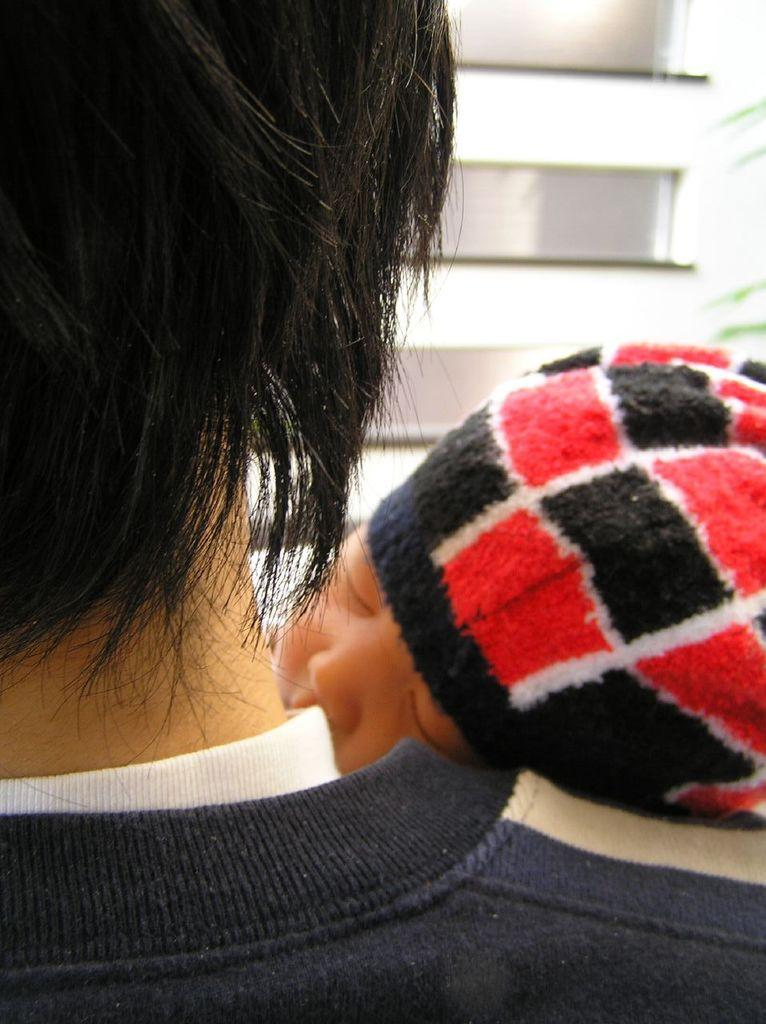What is the main subject of the image? There is a baby in the image. What is the baby doing in the image? The baby is sleeping. Where is the baby positioned in the image? The baby is on the shoulder of a person. What color is the crayon that the baby is holding in the image? There is no crayon present in the image; the baby is sleeping on the shoulder of a person. 